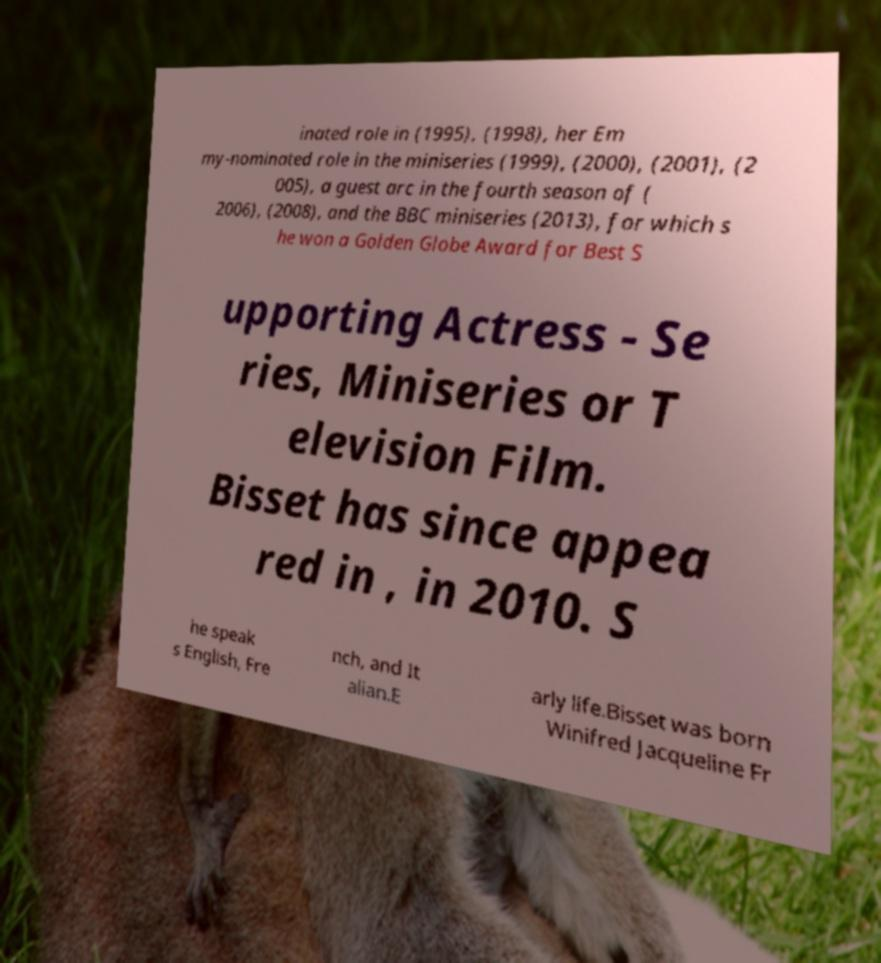There's text embedded in this image that I need extracted. Can you transcribe it verbatim? inated role in (1995), (1998), her Em my-nominated role in the miniseries (1999), (2000), (2001), (2 005), a guest arc in the fourth season of ( 2006), (2008), and the BBC miniseries (2013), for which s he won a Golden Globe Award for Best S upporting Actress - Se ries, Miniseries or T elevision Film. Bisset has since appea red in , in 2010. S he speak s English, Fre nch, and It alian.E arly life.Bisset was born Winifred Jacqueline Fr 